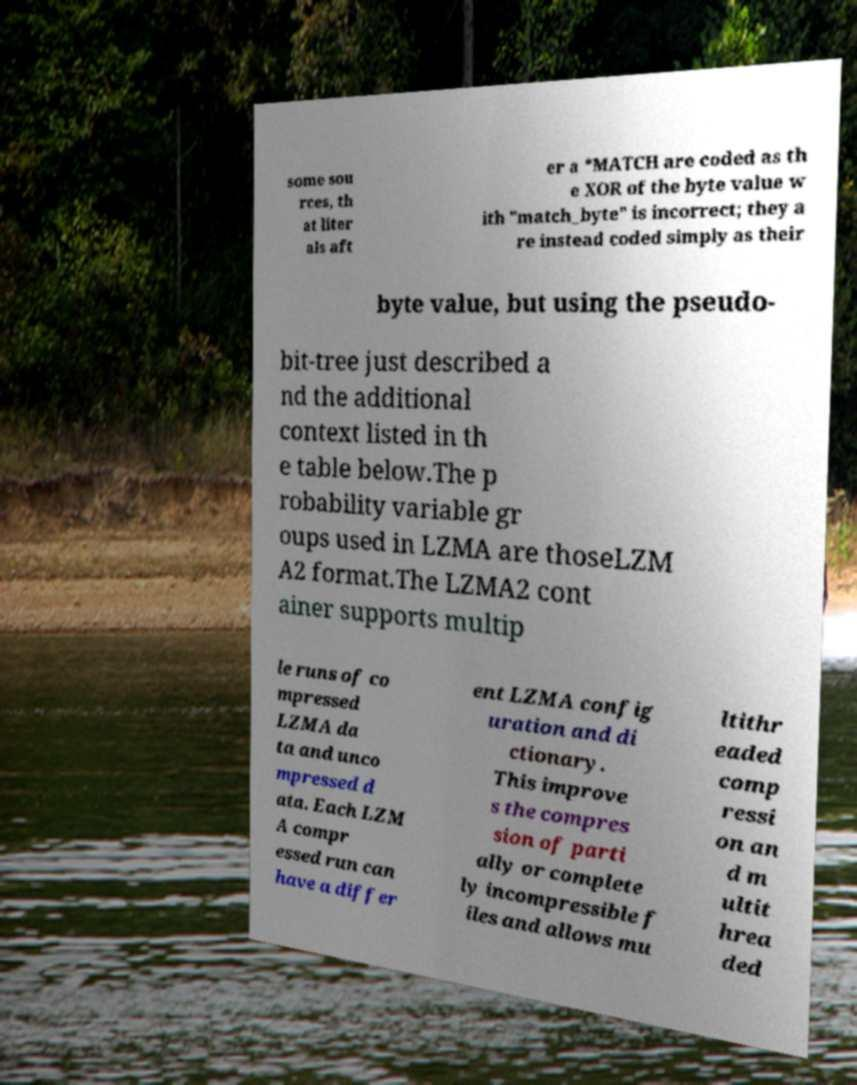Can you read and provide the text displayed in the image?This photo seems to have some interesting text. Can you extract and type it out for me? some sou rces, th at liter als aft er a *MATCH are coded as th e XOR of the byte value w ith "match_byte" is incorrect; they a re instead coded simply as their byte value, but using the pseudo- bit-tree just described a nd the additional context listed in th e table below.The p robability variable gr oups used in LZMA are thoseLZM A2 format.The LZMA2 cont ainer supports multip le runs of co mpressed LZMA da ta and unco mpressed d ata. Each LZM A compr essed run can have a differ ent LZMA config uration and di ctionary. This improve s the compres sion of parti ally or complete ly incompressible f iles and allows mu ltithr eaded comp ressi on an d m ultit hrea ded 